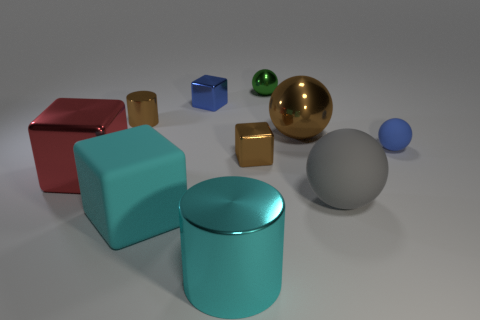What is the shape of the tiny shiny thing that is the same color as the small rubber thing?
Give a very brief answer. Cube. What number of things are both in front of the tiny blue matte sphere and left of the tiny blue metallic block?
Give a very brief answer. 2. What number of objects are gray matte objects or tiny blue objects to the right of the tiny brown metal block?
Keep it short and to the point. 2. Is the number of metallic blocks greater than the number of cubes?
Ensure brevity in your answer.  No. What is the shape of the large rubber object to the left of the large cyan metal cylinder?
Offer a terse response. Cube. What number of small blue shiny things have the same shape as the big brown metal thing?
Your response must be concise. 0. What is the size of the metallic cube behind the small brown metallic cube that is behind the cyan cylinder?
Ensure brevity in your answer.  Small. What number of purple objects are matte things or large rubber spheres?
Give a very brief answer. 0. Is the number of tiny shiny things behind the large brown shiny object less than the number of objects behind the big red cube?
Give a very brief answer. Yes. Is the size of the cyan matte block the same as the metallic cylinder that is on the right side of the tiny brown cylinder?
Provide a short and direct response. Yes. 